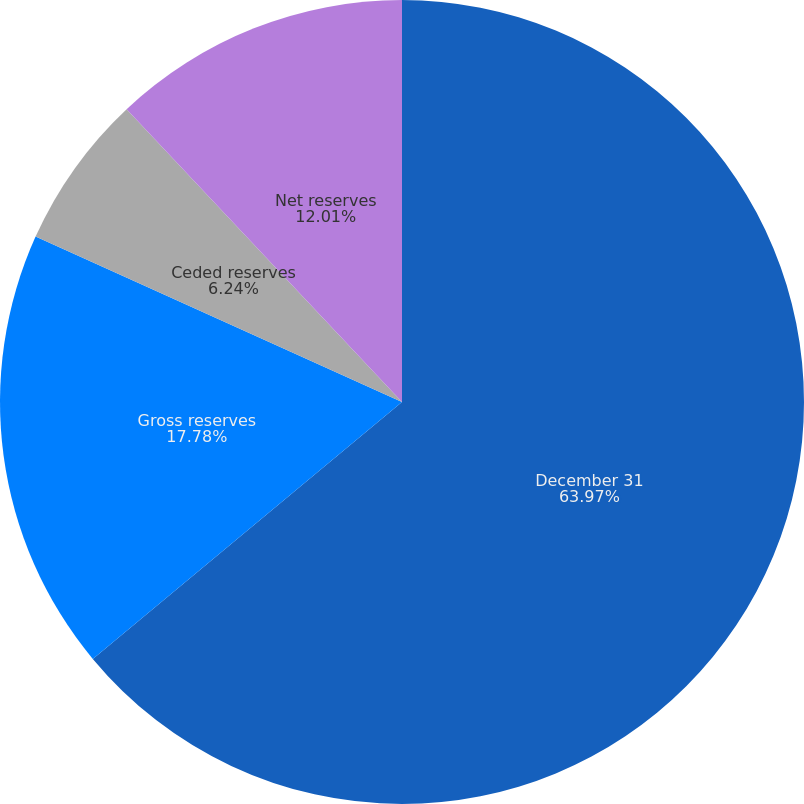Convert chart to OTSL. <chart><loc_0><loc_0><loc_500><loc_500><pie_chart><fcel>December 31<fcel>Gross reserves<fcel>Ceded reserves<fcel>Net reserves<nl><fcel>63.96%<fcel>17.78%<fcel>6.24%<fcel>12.01%<nl></chart> 